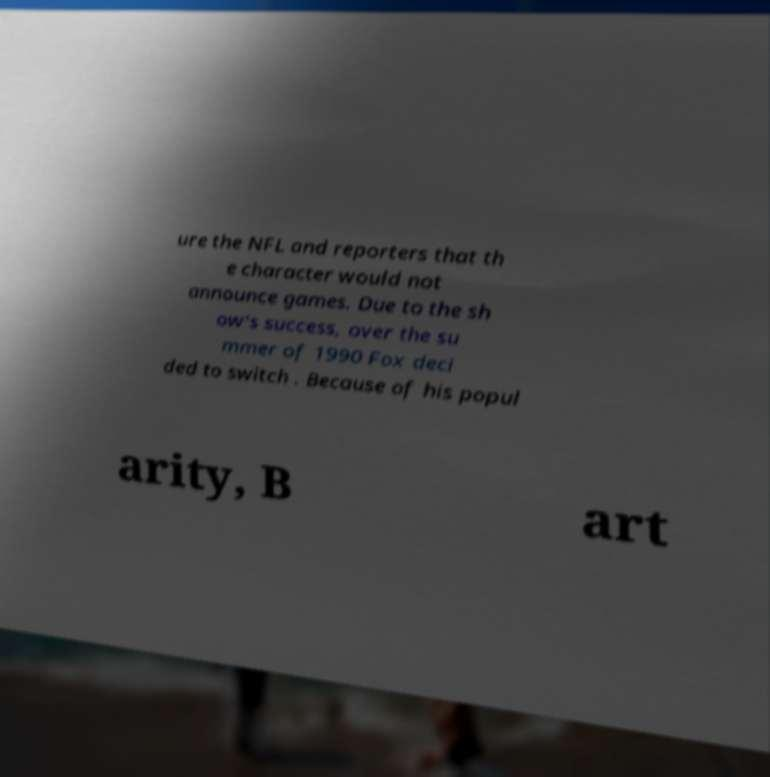Could you extract and type out the text from this image? ure the NFL and reporters that th e character would not announce games. Due to the sh ow's success, over the su mmer of 1990 Fox deci ded to switch . Because of his popul arity, B art 